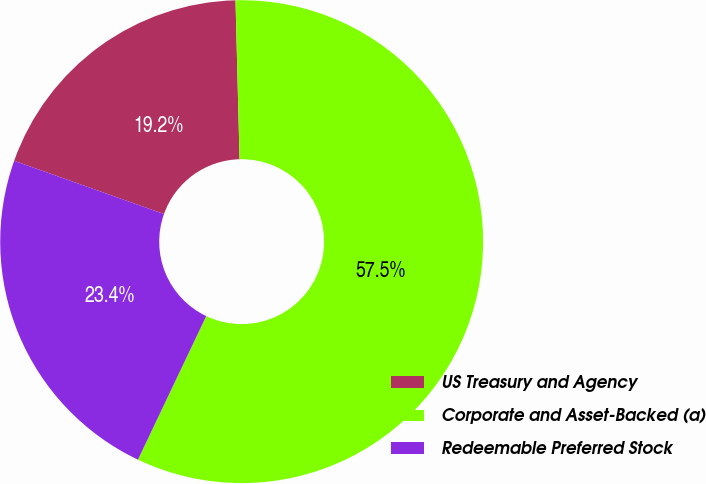Convert chart. <chart><loc_0><loc_0><loc_500><loc_500><pie_chart><fcel>US Treasury and Agency<fcel>Corporate and Asset-Backed (a)<fcel>Redeemable Preferred Stock<nl><fcel>19.16%<fcel>57.47%<fcel>23.37%<nl></chart> 